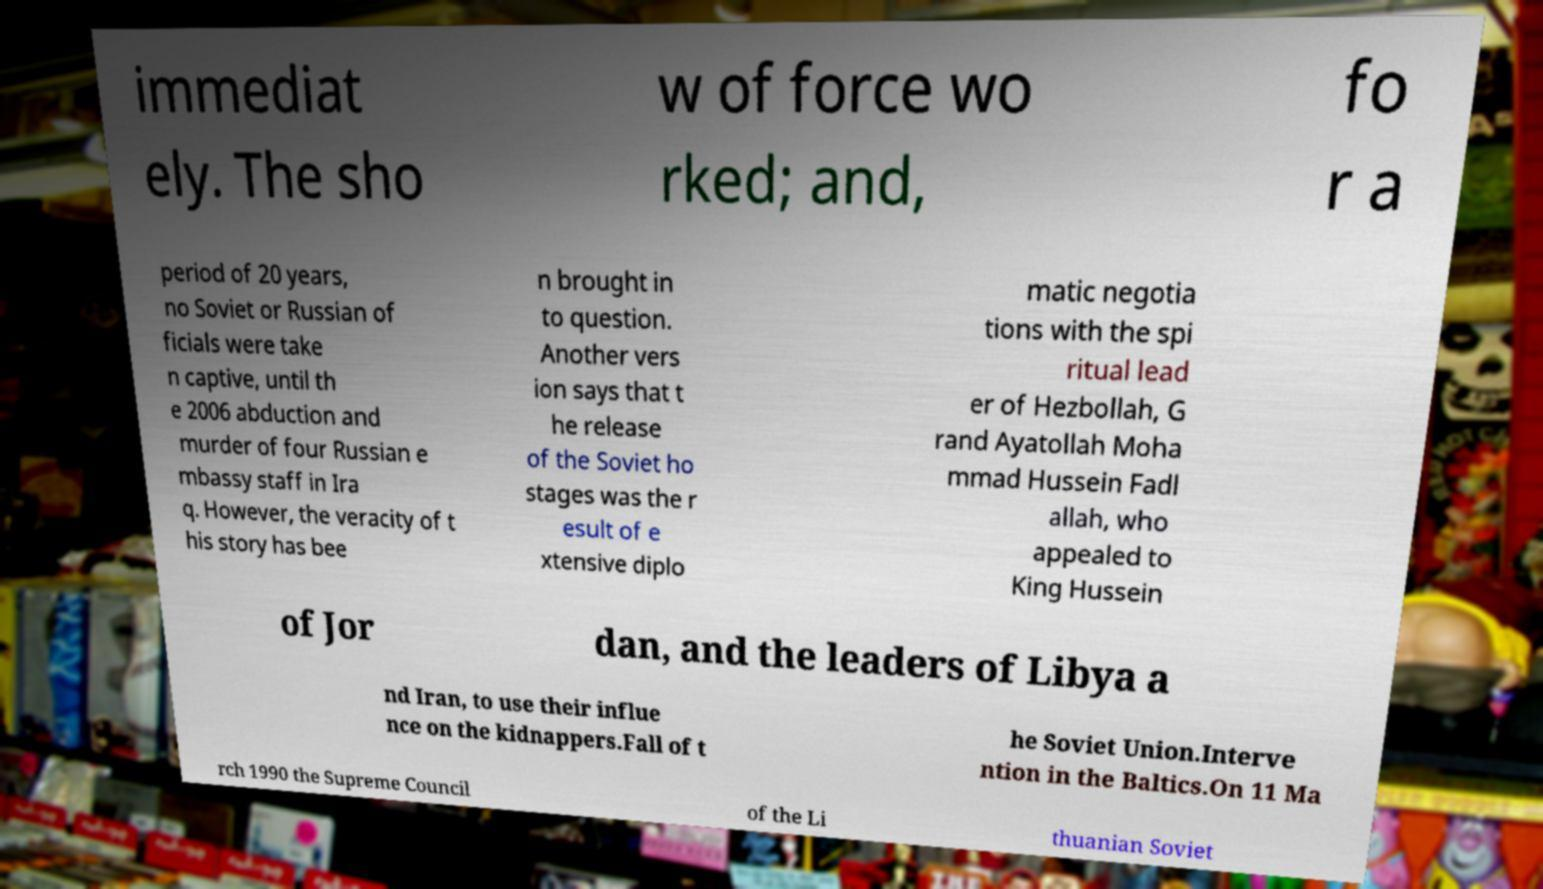Please identify and transcribe the text found in this image. immediat ely. The sho w of force wo rked; and, fo r a period of 20 years, no Soviet or Russian of ficials were take n captive, until th e 2006 abduction and murder of four Russian e mbassy staff in Ira q. However, the veracity of t his story has bee n brought in to question. Another vers ion says that t he release of the Soviet ho stages was the r esult of e xtensive diplo matic negotia tions with the spi ritual lead er of Hezbollah, G rand Ayatollah Moha mmad Hussein Fadl allah, who appealed to King Hussein of Jor dan, and the leaders of Libya a nd Iran, to use their influe nce on the kidnappers.Fall of t he Soviet Union.Interve ntion in the Baltics.On 11 Ma rch 1990 the Supreme Council of the Li thuanian Soviet 